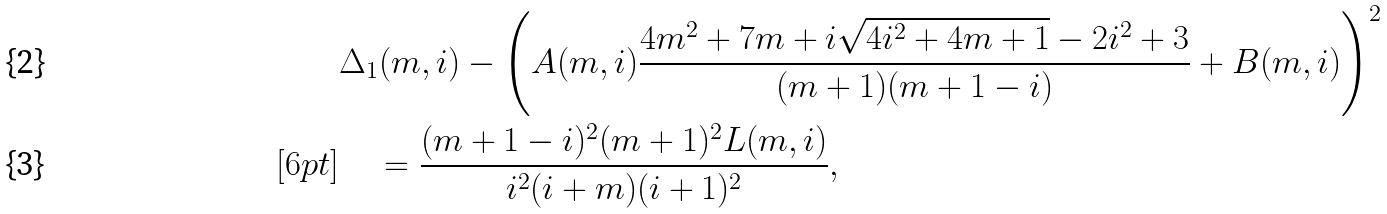Convert formula to latex. <formula><loc_0><loc_0><loc_500><loc_500>& \Delta _ { 1 } ( m , i ) - \left ( A ( m , i ) \frac { 4 m ^ { 2 } + 7 m + i \sqrt { 4 i ^ { 2 } + 4 m + 1 } - 2 i ^ { 2 } + 3 } { ( m + 1 ) ( m + 1 - i ) } + B ( m , i ) \right ) ^ { 2 } \\ [ 6 p t ] & \quad = \frac { ( m + 1 - i ) ^ { 2 } ( m + 1 ) ^ { 2 } L ( m , i ) } { i ^ { 2 } ( i + m ) ( i + 1 ) ^ { 2 } } ,</formula> 